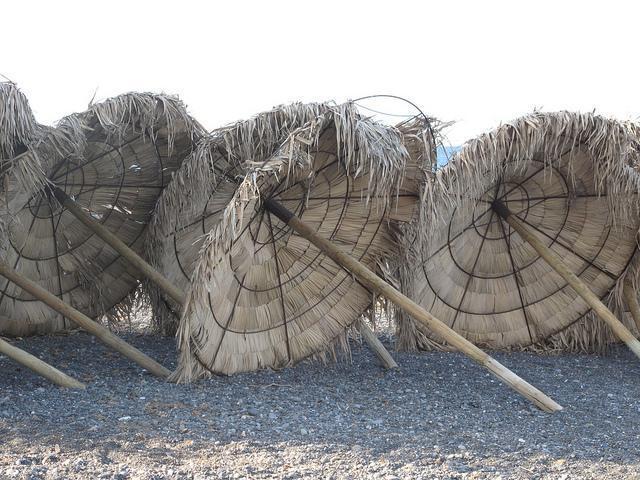How many umbrellas  are these?
Give a very brief answer. 6. How many umbrellas can you see?
Give a very brief answer. 4. 